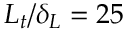<formula> <loc_0><loc_0><loc_500><loc_500>L _ { t } / \delta _ { L } = 2 5</formula> 